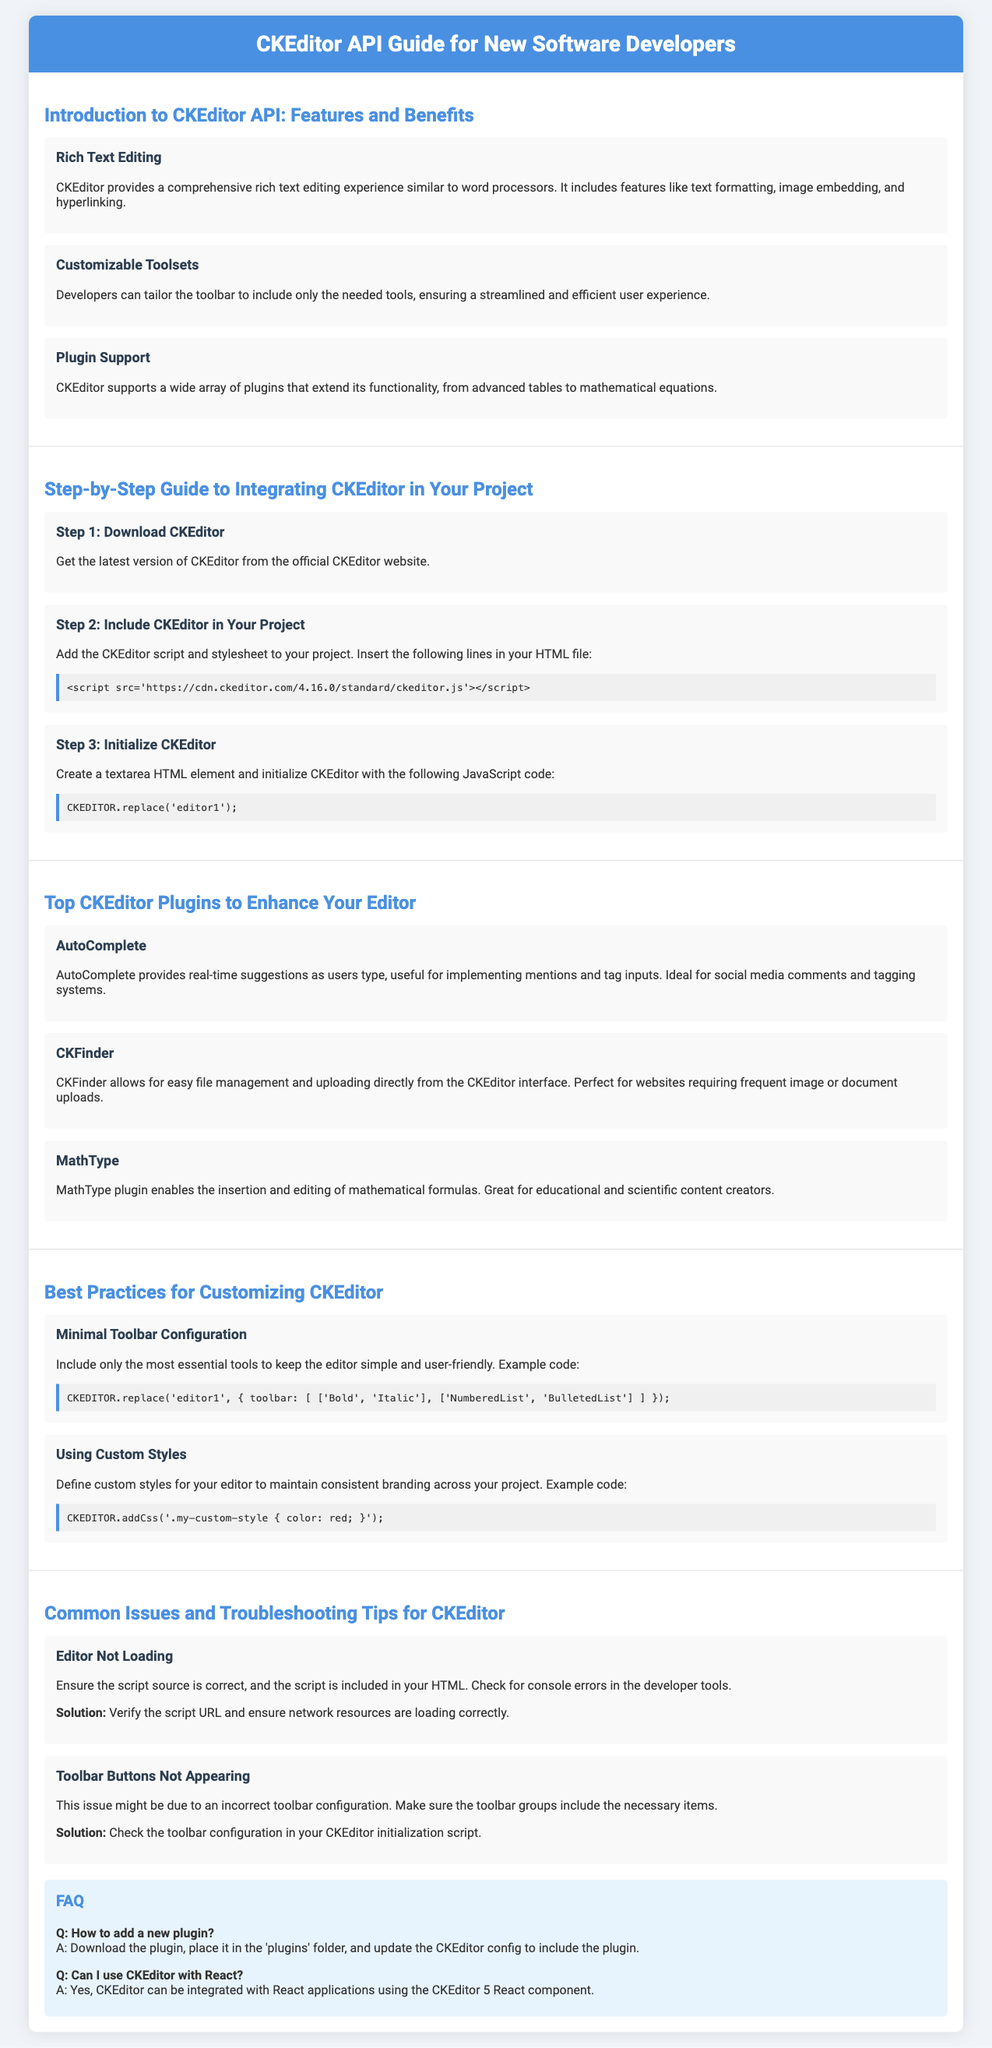What is the title of the document? The document begins with a heading that states its title clearly.
Answer: CKEditor API Guide for New Software Developers What feature allows users to embed images? The document lists features of CKEditor, highlighting one that specifically caters to this functionality.
Answer: Rich Text Editing What is the version number mentioned for CKEditor in the integration steps? The integration guide includes a specific version of CKEditor in the script source.
Answer: 4.16.0 How many steps are outlined for integrating CKEditor? The document details a specific number of steps in a section dedicated to the integration guide.
Answer: 3 Which plugin enables mathematical formula editing? The flyer provides information about multiple plugins, identifying one geared towards mathematical needs.
Answer: MathType What should you check if the CKEditor is not loading? Troubleshooting tips within the document highlight a specific action to take if this issue arises.
Answer: Script source What is one recommended practice for customizing the toolbar? The best practices section includes a recommendation related to the toolbar configuration for enhancing usability.
Answer: Minimal Toolbar Configuration How many common issues are listed for CKEditor? The document enumerates troubles faced by users, providing specific examples of such issues.
Answer: 2 